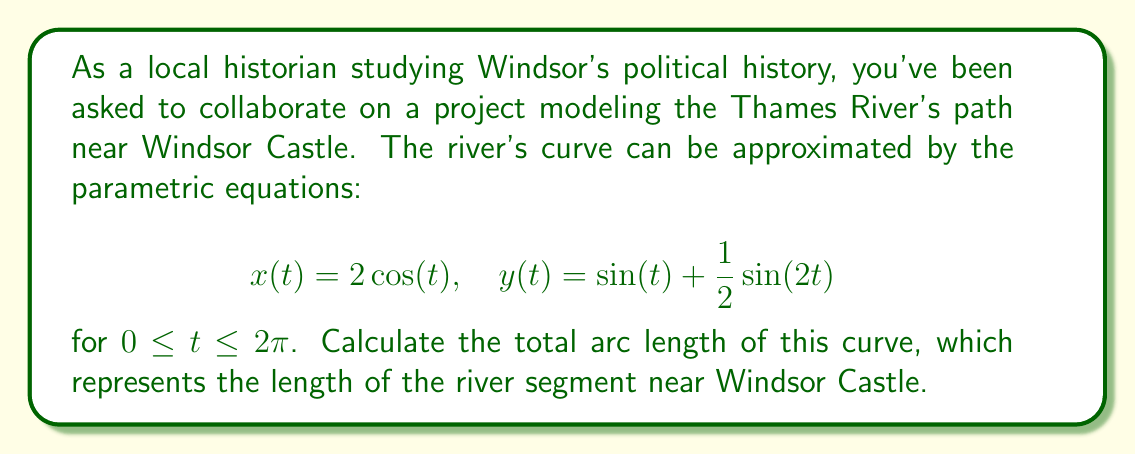Can you answer this question? To find the arc length of a parametric curve, we use the formula:

$$L = \int_a^b \sqrt{\left(\frac{dx}{dt}\right)^2 + \left(\frac{dy}{dt}\right)^2} dt$$

Step 1: Find $\frac{dx}{dt}$ and $\frac{dy}{dt}$
$$\frac{dx}{dt} = -2\sin(t)$$
$$\frac{dy}{dt} = \cos(t) + \cos(2t)$$

Step 2: Substitute into the arc length formula
$$L = \int_0^{2\pi} \sqrt{(-2\sin(t))^2 + (\cos(t) + \cos(2t))^2} dt$$

Step 3: Simplify under the square root
$$L = \int_0^{2\pi} \sqrt{4\sin^2(t) + \cos^2(t) + 2\cos(t)\cos(2t) + \cos^2(2t)} dt$$

Step 4: Use trigonometric identities
$\cos^2(2t) = \frac{1 + \cos(4t)}{2}$
$\cos(t)\cos(2t) = \frac{\cos(t) + \cos(3t)}{2}$

Substituting these:
$$L = \int_0^{2\pi} \sqrt{4\sin^2(t) + \cos^2(t) + \cos(t) + \cos(3t) + \frac{1 + \cos(4t)}{2}} dt$$

Step 5: This integral cannot be solved analytically. We need to use numerical integration methods to approximate the result. Using a computer algebra system or numerical integration tool, we find:

$$L \approx 9.6884$$
Answer: $9.6884$ units 